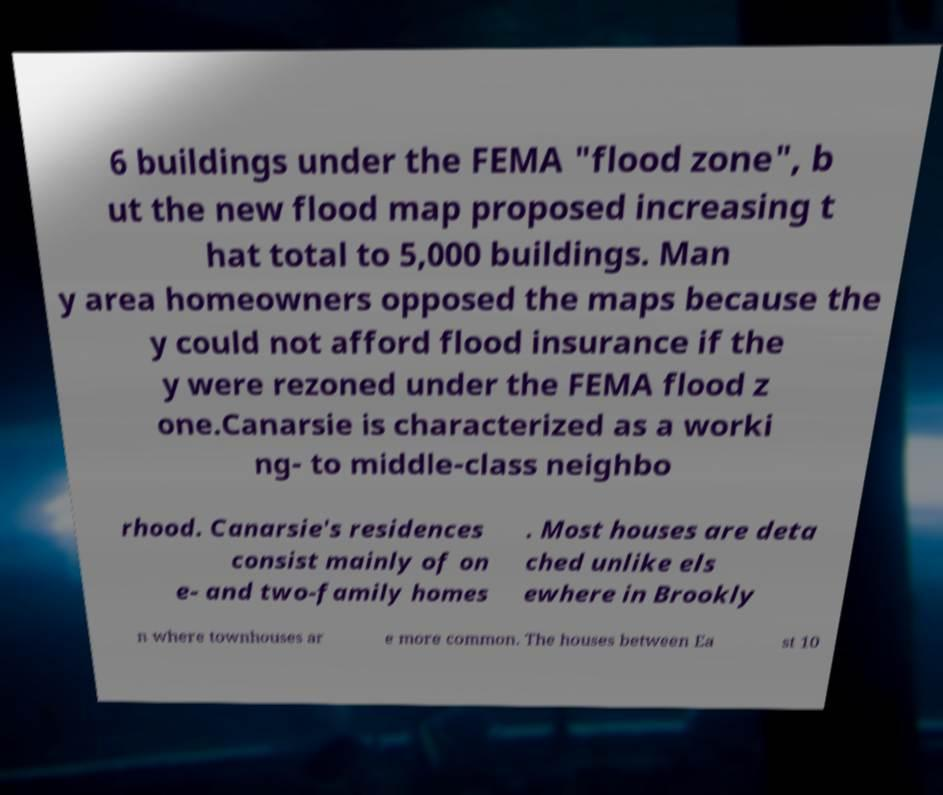Can you read and provide the text displayed in the image?This photo seems to have some interesting text. Can you extract and type it out for me? 6 buildings under the FEMA "flood zone", b ut the new flood map proposed increasing t hat total to 5,000 buildings. Man y area homeowners opposed the maps because the y could not afford flood insurance if the y were rezoned under the FEMA flood z one.Canarsie is characterized as a worki ng- to middle-class neighbo rhood. Canarsie's residences consist mainly of on e- and two-family homes . Most houses are deta ched unlike els ewhere in Brookly n where townhouses ar e more common. The houses between Ea st 10 